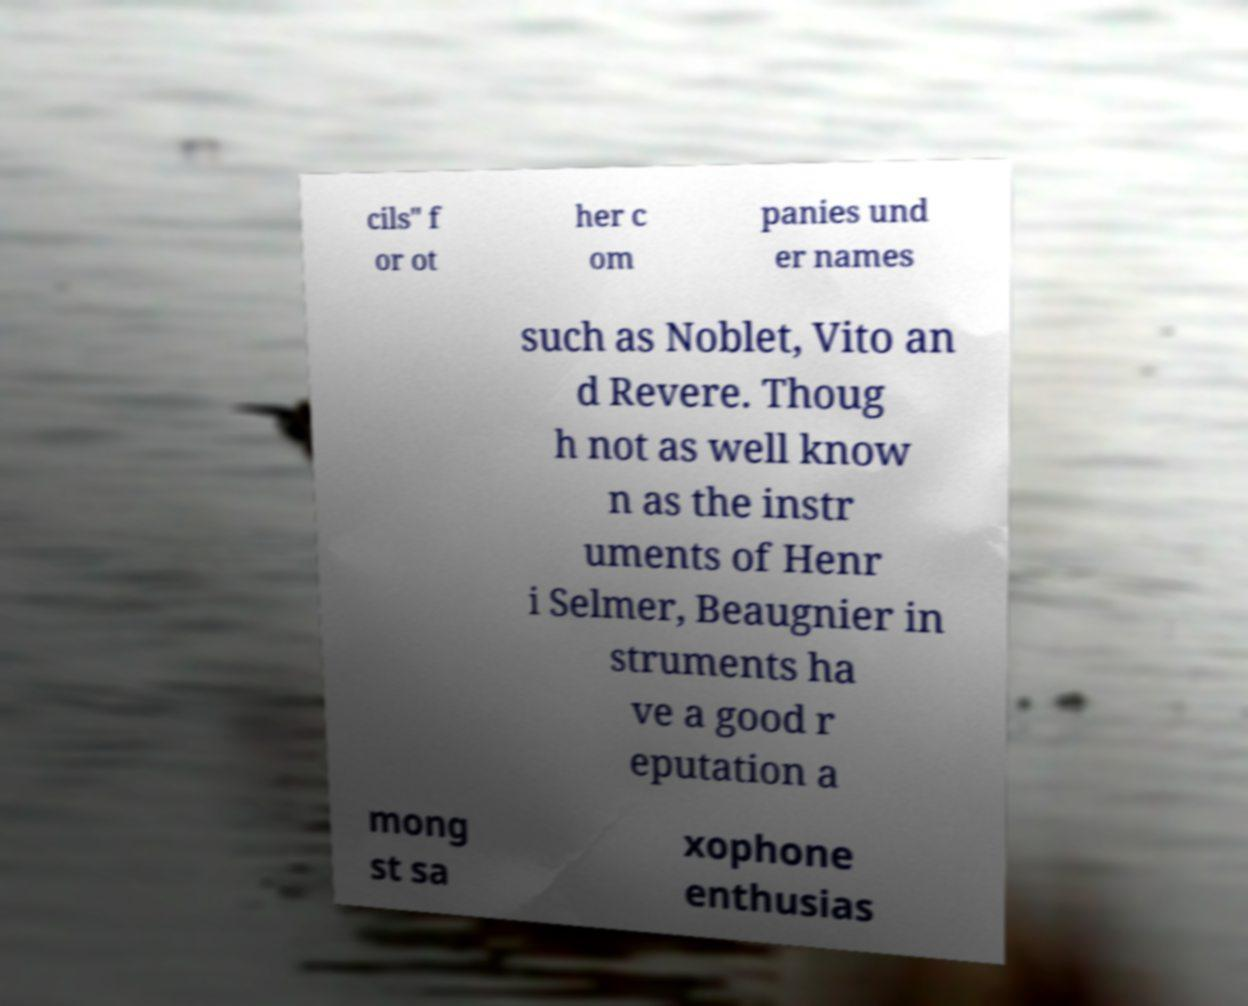Could you extract and type out the text from this image? cils" f or ot her c om panies und er names such as Noblet, Vito an d Revere. Thoug h not as well know n as the instr uments of Henr i Selmer, Beaugnier in struments ha ve a good r eputation a mong st sa xophone enthusias 